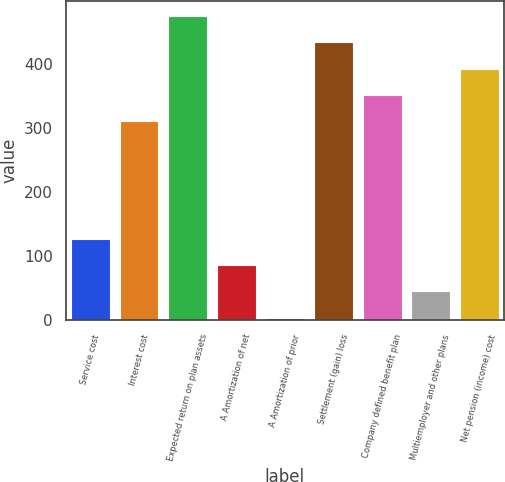<chart> <loc_0><loc_0><loc_500><loc_500><bar_chart><fcel>Service cost<fcel>Interest cost<fcel>Expected return on plan assets<fcel>A Amortization of net<fcel>A Amortization of prior<fcel>Settlement (gain) loss<fcel>Company defined benefit plan<fcel>Multiemployer and other plans<fcel>Net pension (income) cost<nl><fcel>126.42<fcel>310.3<fcel>474.32<fcel>85.58<fcel>3.9<fcel>433.48<fcel>351.8<fcel>44.74<fcel>392.64<nl></chart> 